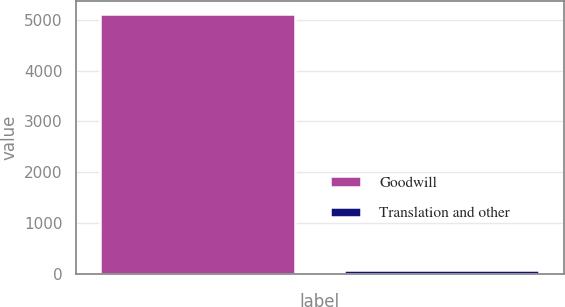Convert chart to OTSL. <chart><loc_0><loc_0><loc_500><loc_500><bar_chart><fcel>Goodwill<fcel>Translation and other<nl><fcel>5115<fcel>73<nl></chart> 